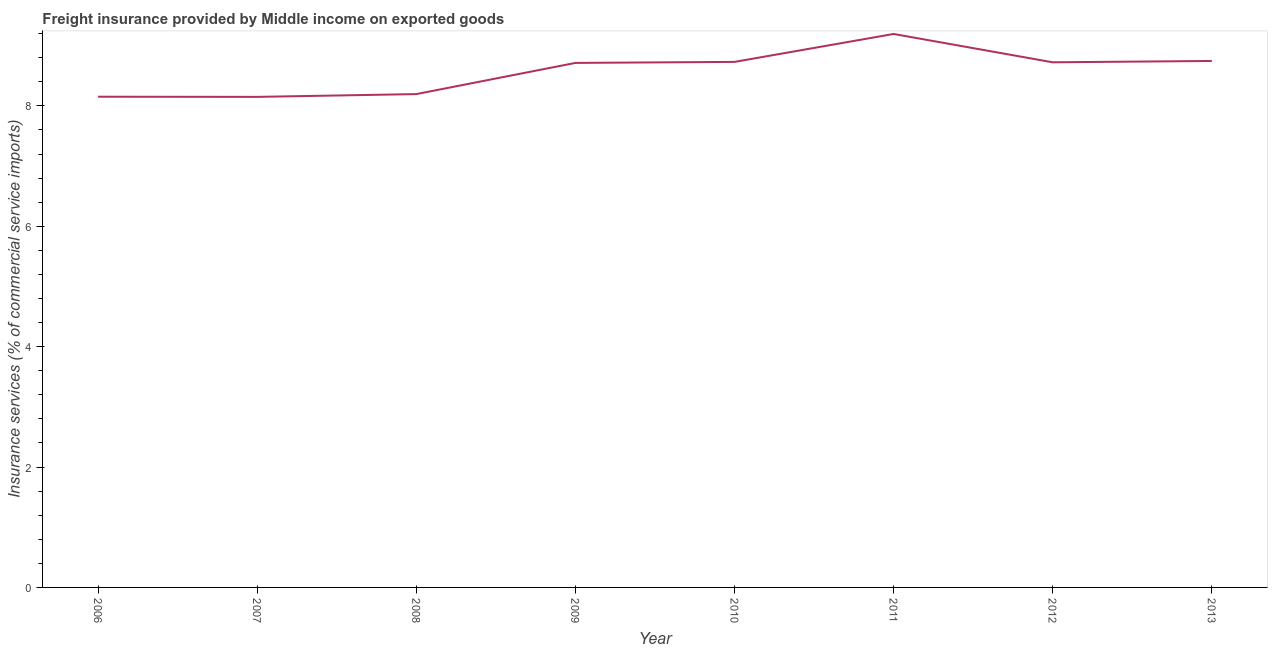What is the freight insurance in 2008?
Offer a very short reply. 8.2. Across all years, what is the maximum freight insurance?
Your answer should be very brief. 9.2. Across all years, what is the minimum freight insurance?
Your answer should be very brief. 8.15. In which year was the freight insurance maximum?
Your answer should be very brief. 2011. What is the sum of the freight insurance?
Provide a short and direct response. 68.61. What is the difference between the freight insurance in 2012 and 2013?
Offer a very short reply. -0.02. What is the average freight insurance per year?
Provide a short and direct response. 8.58. What is the median freight insurance?
Your answer should be compact. 8.72. In how many years, is the freight insurance greater than 3.6 %?
Your answer should be compact. 8. What is the ratio of the freight insurance in 2007 to that in 2009?
Provide a succinct answer. 0.94. What is the difference between the highest and the second highest freight insurance?
Offer a very short reply. 0.45. Is the sum of the freight insurance in 2006 and 2012 greater than the maximum freight insurance across all years?
Ensure brevity in your answer.  Yes. What is the difference between the highest and the lowest freight insurance?
Your answer should be compact. 1.05. Does the freight insurance monotonically increase over the years?
Provide a succinct answer. No. Are the values on the major ticks of Y-axis written in scientific E-notation?
Ensure brevity in your answer.  No. Does the graph contain any zero values?
Offer a very short reply. No. What is the title of the graph?
Offer a terse response. Freight insurance provided by Middle income on exported goods . What is the label or title of the Y-axis?
Your answer should be compact. Insurance services (% of commercial service imports). What is the Insurance services (% of commercial service imports) of 2006?
Provide a short and direct response. 8.15. What is the Insurance services (% of commercial service imports) in 2007?
Your response must be concise. 8.15. What is the Insurance services (% of commercial service imports) in 2008?
Your response must be concise. 8.2. What is the Insurance services (% of commercial service imports) in 2009?
Offer a terse response. 8.71. What is the Insurance services (% of commercial service imports) in 2010?
Provide a succinct answer. 8.73. What is the Insurance services (% of commercial service imports) of 2011?
Your response must be concise. 9.2. What is the Insurance services (% of commercial service imports) of 2012?
Make the answer very short. 8.72. What is the Insurance services (% of commercial service imports) of 2013?
Your answer should be very brief. 8.75. What is the difference between the Insurance services (% of commercial service imports) in 2006 and 2007?
Ensure brevity in your answer.  0. What is the difference between the Insurance services (% of commercial service imports) in 2006 and 2008?
Make the answer very short. -0.04. What is the difference between the Insurance services (% of commercial service imports) in 2006 and 2009?
Your response must be concise. -0.56. What is the difference between the Insurance services (% of commercial service imports) in 2006 and 2010?
Your answer should be very brief. -0.58. What is the difference between the Insurance services (% of commercial service imports) in 2006 and 2011?
Ensure brevity in your answer.  -1.04. What is the difference between the Insurance services (% of commercial service imports) in 2006 and 2012?
Offer a very short reply. -0.57. What is the difference between the Insurance services (% of commercial service imports) in 2006 and 2013?
Your answer should be compact. -0.59. What is the difference between the Insurance services (% of commercial service imports) in 2007 and 2008?
Provide a succinct answer. -0.05. What is the difference between the Insurance services (% of commercial service imports) in 2007 and 2009?
Keep it short and to the point. -0.56. What is the difference between the Insurance services (% of commercial service imports) in 2007 and 2010?
Your answer should be compact. -0.58. What is the difference between the Insurance services (% of commercial service imports) in 2007 and 2011?
Provide a short and direct response. -1.05. What is the difference between the Insurance services (% of commercial service imports) in 2007 and 2012?
Your response must be concise. -0.57. What is the difference between the Insurance services (% of commercial service imports) in 2007 and 2013?
Give a very brief answer. -0.6. What is the difference between the Insurance services (% of commercial service imports) in 2008 and 2009?
Make the answer very short. -0.52. What is the difference between the Insurance services (% of commercial service imports) in 2008 and 2010?
Make the answer very short. -0.54. What is the difference between the Insurance services (% of commercial service imports) in 2008 and 2011?
Give a very brief answer. -1. What is the difference between the Insurance services (% of commercial service imports) in 2008 and 2012?
Provide a succinct answer. -0.53. What is the difference between the Insurance services (% of commercial service imports) in 2008 and 2013?
Keep it short and to the point. -0.55. What is the difference between the Insurance services (% of commercial service imports) in 2009 and 2010?
Your answer should be compact. -0.02. What is the difference between the Insurance services (% of commercial service imports) in 2009 and 2011?
Provide a short and direct response. -0.48. What is the difference between the Insurance services (% of commercial service imports) in 2009 and 2012?
Make the answer very short. -0.01. What is the difference between the Insurance services (% of commercial service imports) in 2009 and 2013?
Offer a very short reply. -0.03. What is the difference between the Insurance services (% of commercial service imports) in 2010 and 2011?
Provide a succinct answer. -0.46. What is the difference between the Insurance services (% of commercial service imports) in 2010 and 2012?
Offer a terse response. 0.01. What is the difference between the Insurance services (% of commercial service imports) in 2010 and 2013?
Offer a terse response. -0.02. What is the difference between the Insurance services (% of commercial service imports) in 2011 and 2012?
Ensure brevity in your answer.  0.47. What is the difference between the Insurance services (% of commercial service imports) in 2011 and 2013?
Ensure brevity in your answer.  0.45. What is the difference between the Insurance services (% of commercial service imports) in 2012 and 2013?
Your response must be concise. -0.02. What is the ratio of the Insurance services (% of commercial service imports) in 2006 to that in 2007?
Your answer should be very brief. 1. What is the ratio of the Insurance services (% of commercial service imports) in 2006 to that in 2009?
Make the answer very short. 0.94. What is the ratio of the Insurance services (% of commercial service imports) in 2006 to that in 2010?
Keep it short and to the point. 0.93. What is the ratio of the Insurance services (% of commercial service imports) in 2006 to that in 2011?
Your response must be concise. 0.89. What is the ratio of the Insurance services (% of commercial service imports) in 2006 to that in 2012?
Ensure brevity in your answer.  0.93. What is the ratio of the Insurance services (% of commercial service imports) in 2006 to that in 2013?
Make the answer very short. 0.93. What is the ratio of the Insurance services (% of commercial service imports) in 2007 to that in 2008?
Offer a very short reply. 0.99. What is the ratio of the Insurance services (% of commercial service imports) in 2007 to that in 2009?
Your answer should be very brief. 0.94. What is the ratio of the Insurance services (% of commercial service imports) in 2007 to that in 2010?
Your answer should be compact. 0.93. What is the ratio of the Insurance services (% of commercial service imports) in 2007 to that in 2011?
Your answer should be compact. 0.89. What is the ratio of the Insurance services (% of commercial service imports) in 2007 to that in 2012?
Your answer should be compact. 0.93. What is the ratio of the Insurance services (% of commercial service imports) in 2007 to that in 2013?
Provide a succinct answer. 0.93. What is the ratio of the Insurance services (% of commercial service imports) in 2008 to that in 2009?
Make the answer very short. 0.94. What is the ratio of the Insurance services (% of commercial service imports) in 2008 to that in 2010?
Provide a succinct answer. 0.94. What is the ratio of the Insurance services (% of commercial service imports) in 2008 to that in 2011?
Provide a succinct answer. 0.89. What is the ratio of the Insurance services (% of commercial service imports) in 2008 to that in 2012?
Keep it short and to the point. 0.94. What is the ratio of the Insurance services (% of commercial service imports) in 2008 to that in 2013?
Your answer should be very brief. 0.94. What is the ratio of the Insurance services (% of commercial service imports) in 2009 to that in 2010?
Provide a short and direct response. 1. What is the ratio of the Insurance services (% of commercial service imports) in 2009 to that in 2011?
Your response must be concise. 0.95. What is the ratio of the Insurance services (% of commercial service imports) in 2009 to that in 2012?
Your answer should be very brief. 1. What is the ratio of the Insurance services (% of commercial service imports) in 2009 to that in 2013?
Offer a very short reply. 1. What is the ratio of the Insurance services (% of commercial service imports) in 2010 to that in 2011?
Your answer should be very brief. 0.95. What is the ratio of the Insurance services (% of commercial service imports) in 2010 to that in 2012?
Offer a terse response. 1. What is the ratio of the Insurance services (% of commercial service imports) in 2010 to that in 2013?
Offer a terse response. 1. What is the ratio of the Insurance services (% of commercial service imports) in 2011 to that in 2012?
Your answer should be very brief. 1.05. What is the ratio of the Insurance services (% of commercial service imports) in 2011 to that in 2013?
Give a very brief answer. 1.05. What is the ratio of the Insurance services (% of commercial service imports) in 2012 to that in 2013?
Keep it short and to the point. 1. 